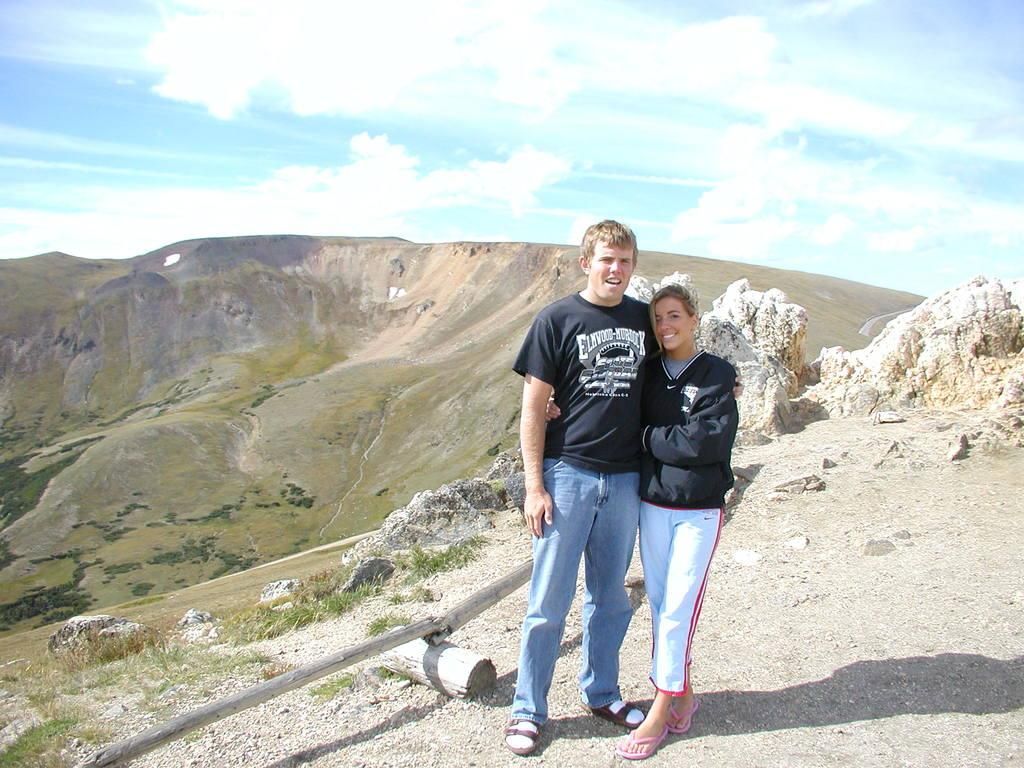How many people are in the image? There are two persons standing in the middle of the image. What are the people in the image doing? The persons are smiling. What can be seen in the background of the image? There are hills visible in the background of the image. What is visible at the top of the image? There are clouds and the sky visible at the top of the image. What type of basin is visible in the image? There is no basin present in the image. Can you hear the bells ringing in the image? There is no mention of bells or any sound in the image, so it cannot be determined if they are ringing. 